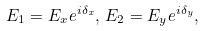<formula> <loc_0><loc_0><loc_500><loc_500>E _ { 1 } = E _ { x } e ^ { i \delta _ { x } } , \, E _ { 2 } = E _ { y } e ^ { i \delta _ { y } } ,</formula> 